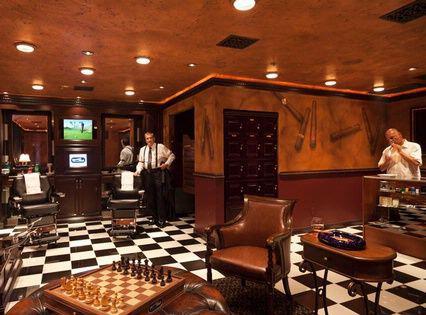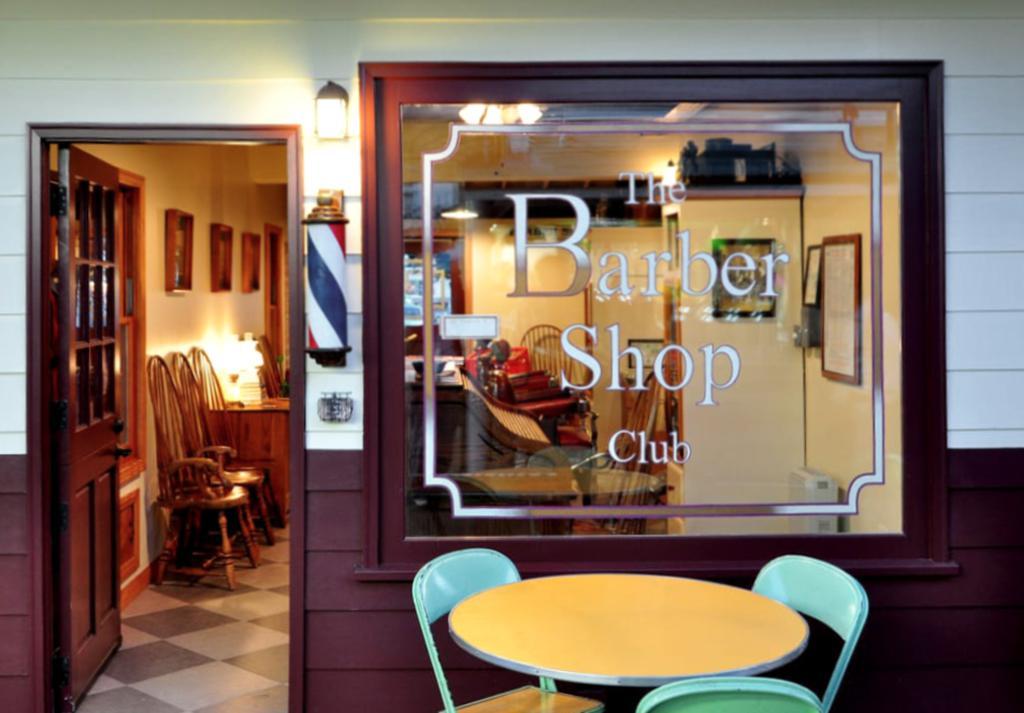The first image is the image on the left, the second image is the image on the right. For the images shown, is this caption "In one of the images there is a checkered floor and in the other image there is a wooden floor." true? Answer yes or no. No. The first image is the image on the left, the second image is the image on the right. Evaluate the accuracy of this statement regarding the images: "There are people in one image but not in the other image.". Is it true? Answer yes or no. Yes. 